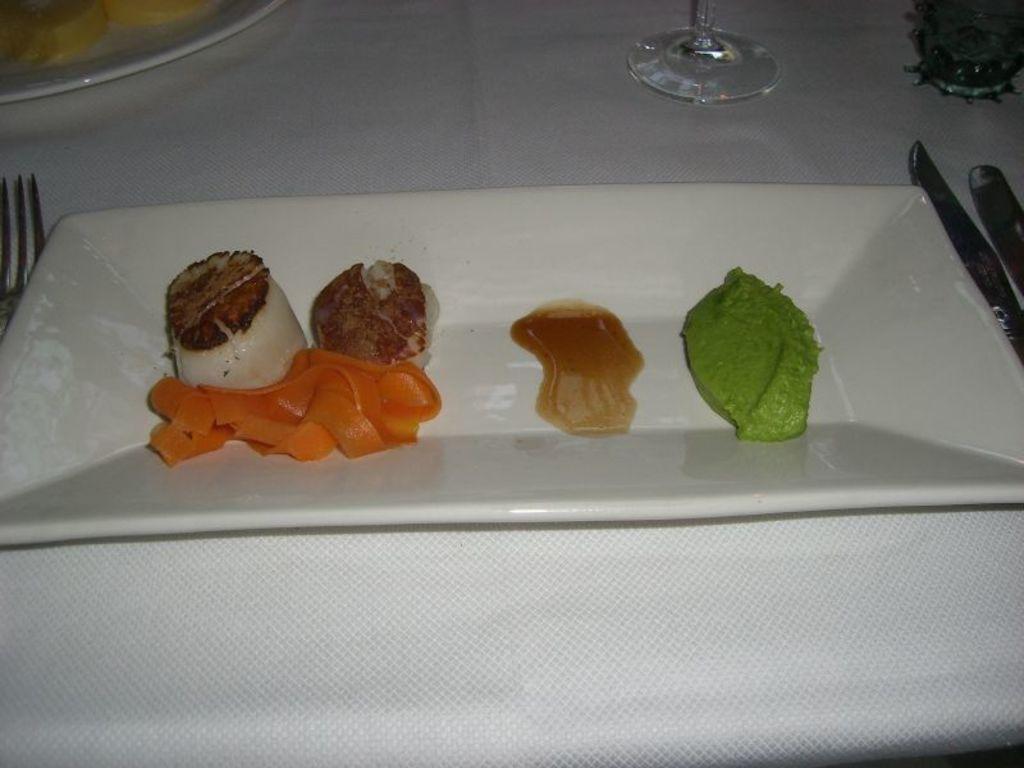Please provide a concise description of this image. In this image we can see some food items kept on a white plate. Here we can see fork, knife, another plate and glass are kept on the table having a white color table cloth on it. 